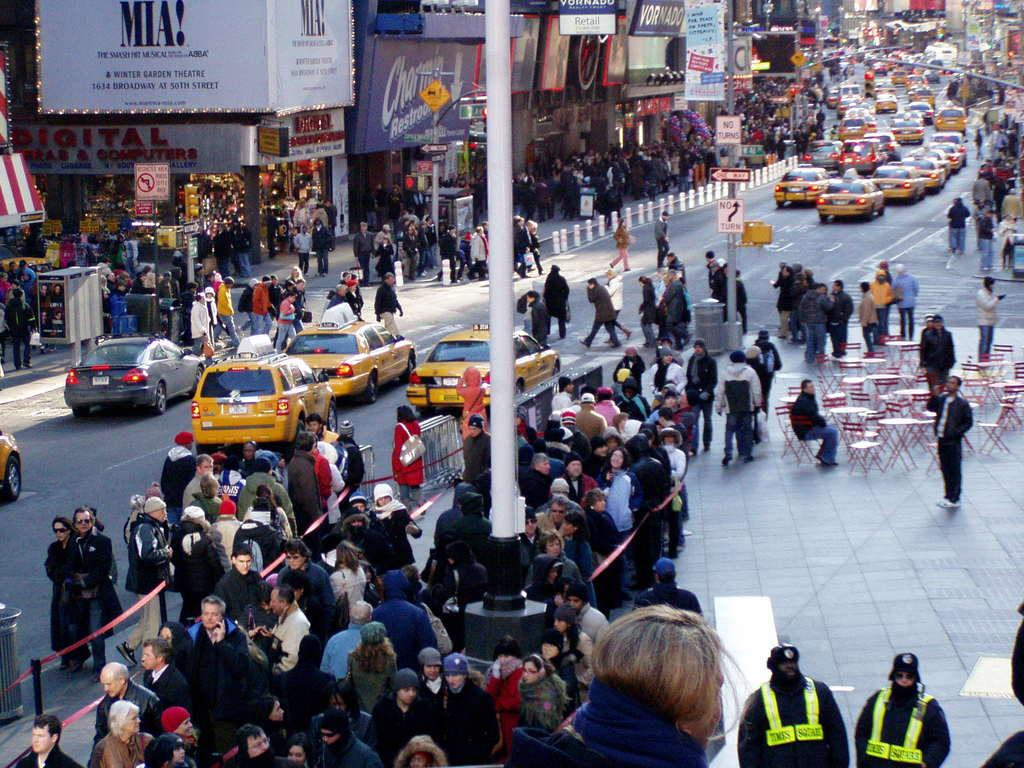<image>
Offer a succinct explanation of the picture presented. A crowded street with a bunch of cabs and people with a marque that says MIA! on it. 